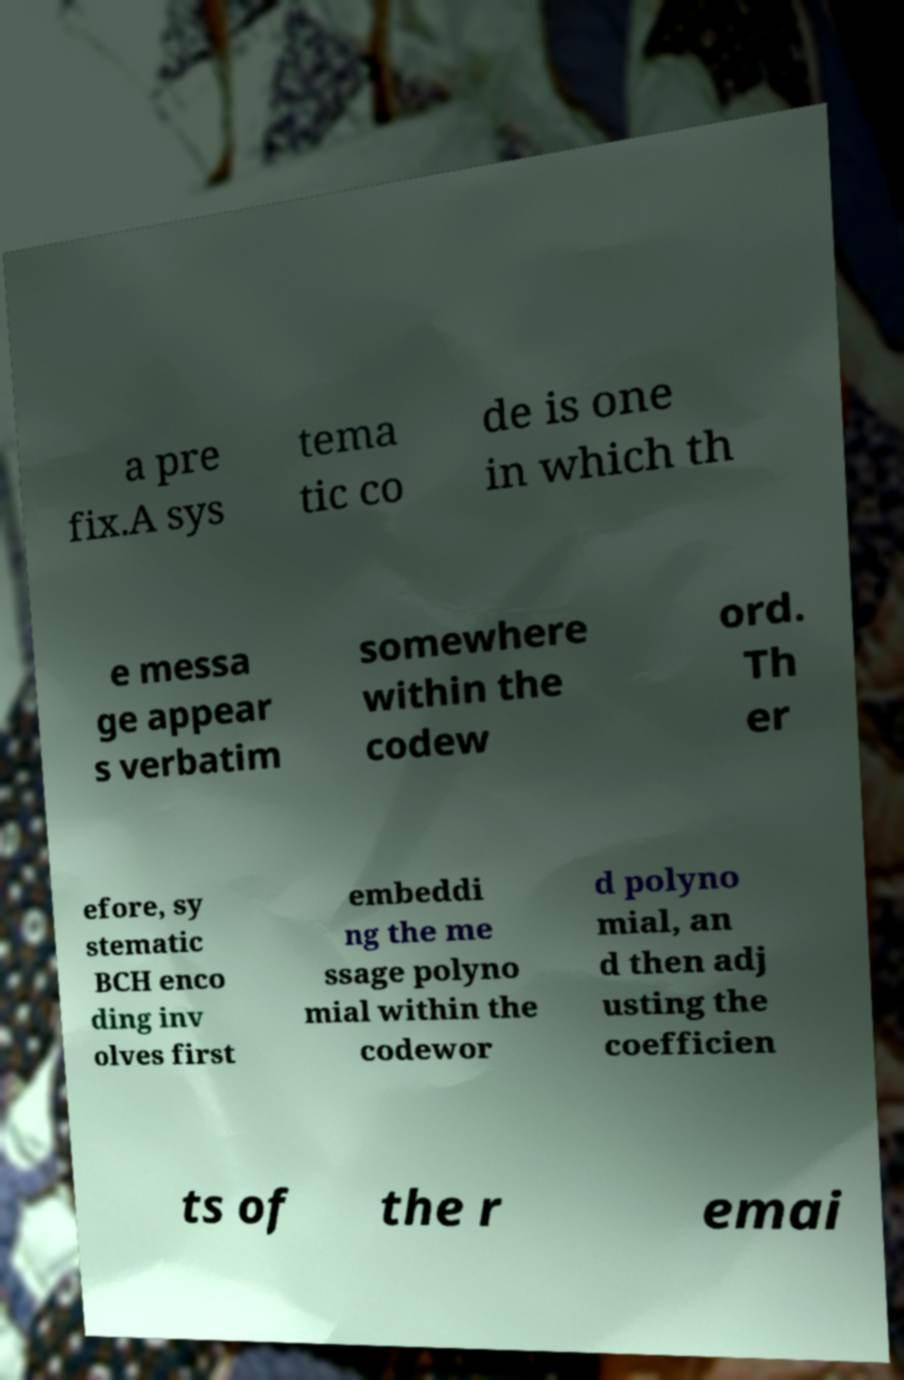Please read and relay the text visible in this image. What does it say? a pre fix.A sys tema tic co de is one in which th e messa ge appear s verbatim somewhere within the codew ord. Th er efore, sy stematic BCH enco ding inv olves first embeddi ng the me ssage polyno mial within the codewor d polyno mial, an d then adj usting the coefficien ts of the r emai 